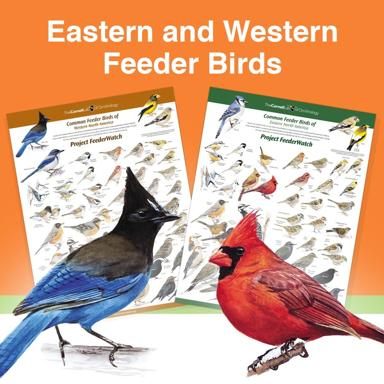What is the significance of having separate posters for Eastern and Western feeder birds? Having separate posters for Eastern and Western feeder birds plays a crucial role in ornithological studies and bird watching, serving as educational tools that facilitate easy identification and comparative analysis. These posters help enthusiasts and researchers understand geographic variations in species, which is pivotal for biodiversity studies and conservation initiatives. They also promote greater awareness among the public, helping in the preservation of avian habits and the encouragement of regional bird watching activities. 